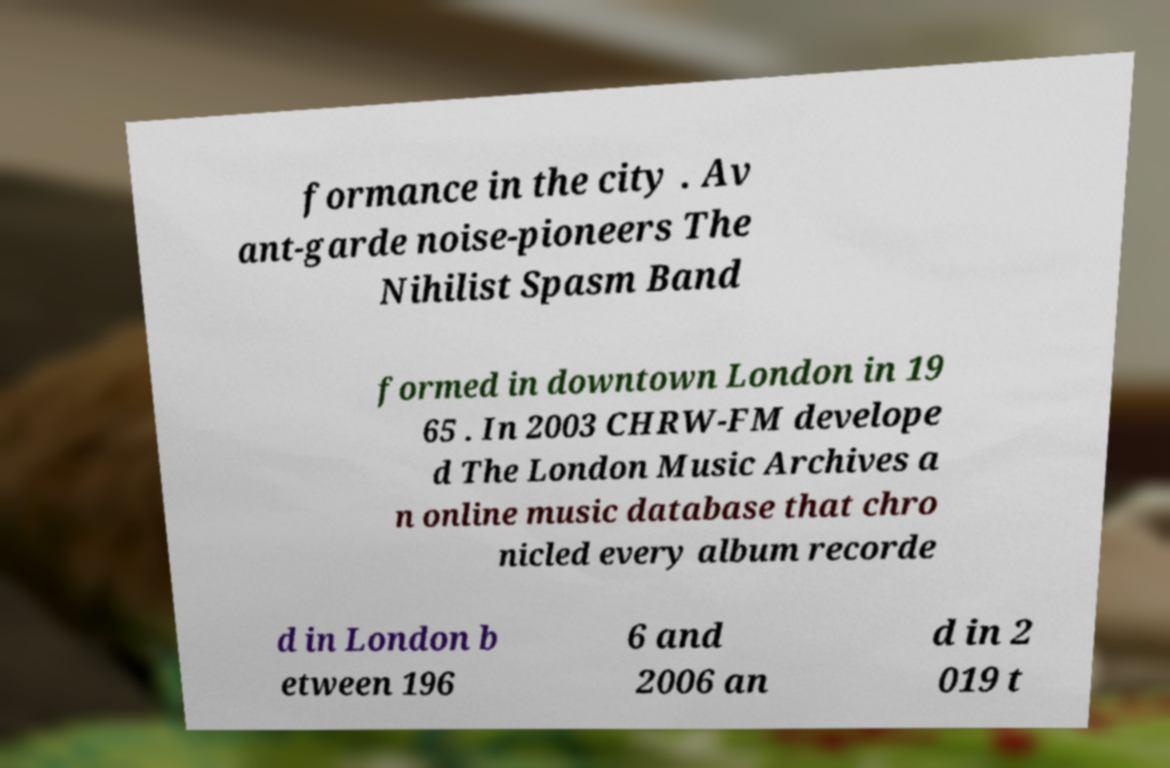Could you extract and type out the text from this image? formance in the city . Av ant-garde noise-pioneers The Nihilist Spasm Band formed in downtown London in 19 65 . In 2003 CHRW-FM develope d The London Music Archives a n online music database that chro nicled every album recorde d in London b etween 196 6 and 2006 an d in 2 019 t 